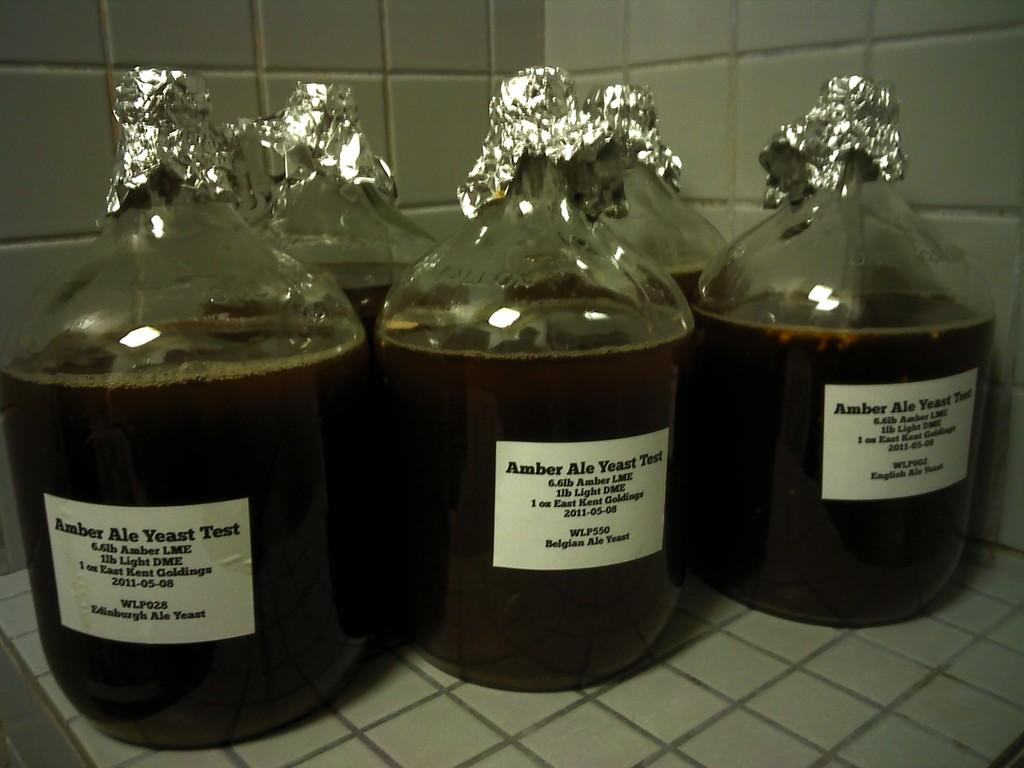<image>
Offer a succinct explanation of the picture presented. large jugs of Amber Ale Yeast Test sit on a tiled surface 